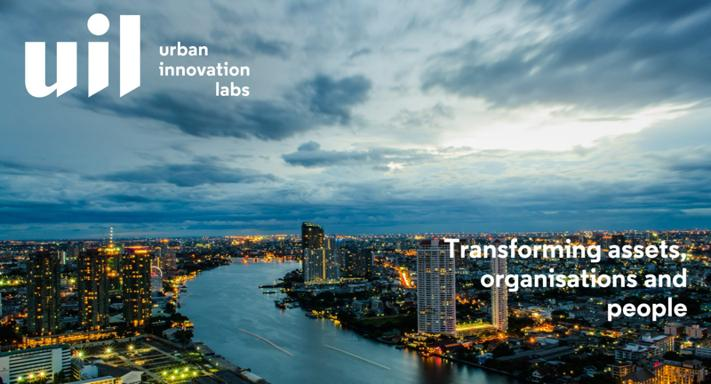What is UIL Urban Innovation Labs? UIL Urban Innovation Labs is an organization dedicated to fostering transformative change in urban environments. It functions as a hub for innovation, working collaboratively to rejuvenate city assets, organizational structures, and civic engagement, aiming to make cities more sustainable, efficient, and livable. 